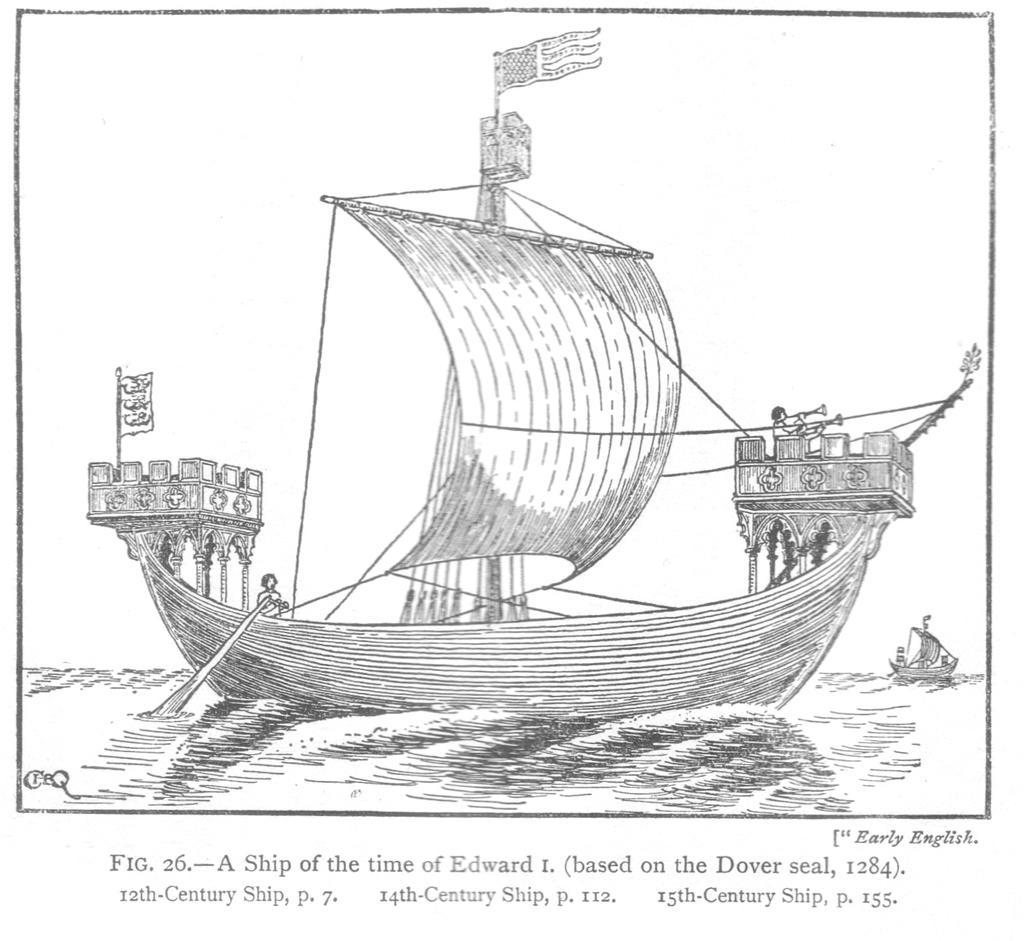Could you give a brief overview of what you see in this image? We can see drawing of boats above the water and there are people in a boat. At the bottom of the image we can see text. 